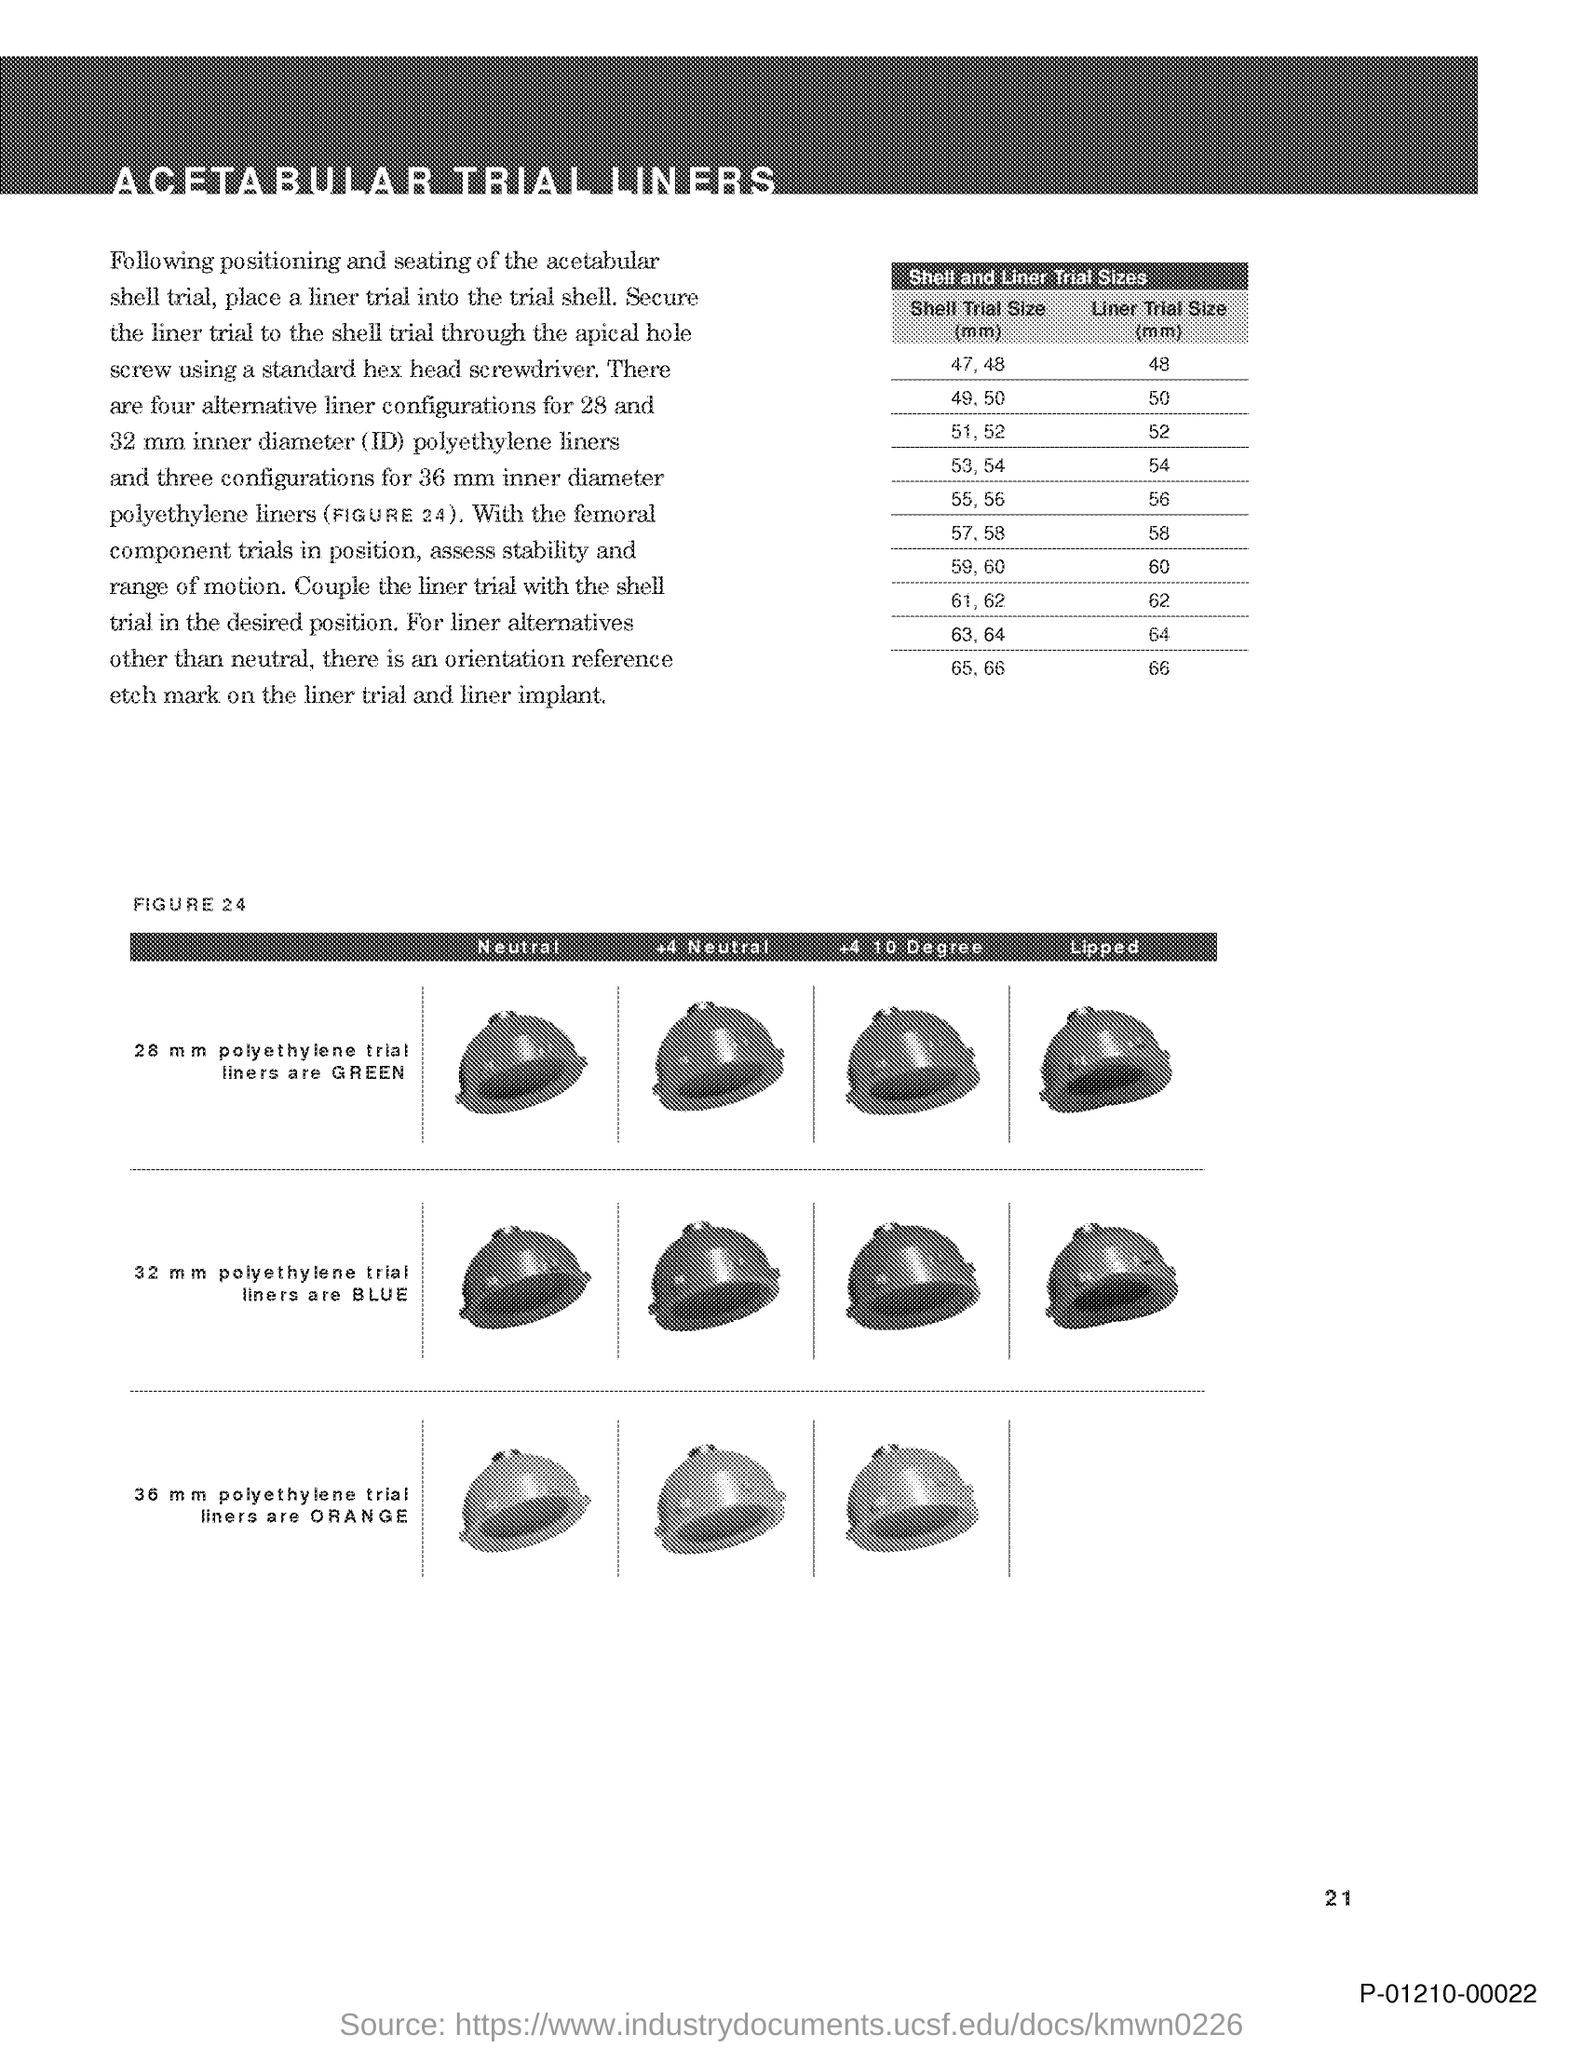What is the document title?
Provide a succinct answer. ACETABULAR TRIAL LINERS. What is the table title?
Your answer should be very brief. Shell and Liner Trial Sizes. What is the liner trial size corresponding to shell trial size of 47,48 mm?
Your answer should be very brief. 48. 